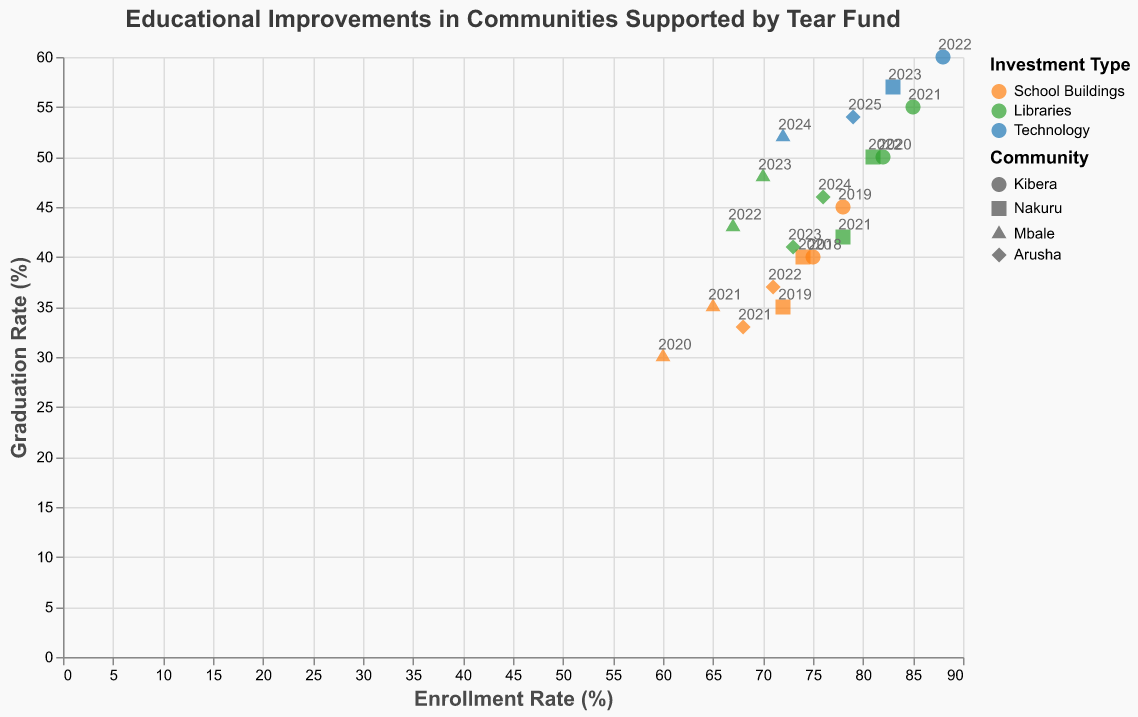How many communities have data points in this figure? The shape legend shows symbols representing different communities. There are four different symbols: circle, square, triangle, and diamond, indicating four communities.
Answer: Four What is the graduation rate for Nakuru in 2023? Find the data point associated with Nakuru in 2023 using its unique shape (square) and year label (2023). The scatter plot indicates a graduation rate of 57%.
Answer: 57% Which community had the highest enrollment rate in 2022? Locate the data points for 2022 and compare the enrollment rates for each community. Kibera had the highest enrollment rate in 2022, marked with a circle and an enrollment rate of 88%.
Answer: Kibera What is the range of investment amounts for library projects? Observe the color legend for libraries (green) and identify the investment amounts visually from these data points. The range is from 15,000 to 25,000 units.
Answer: 15,000 to 25,000 How has the graduation rate in Kibera changed from 2018 to 2022? Identify the data points for Kibera across the years 2018 to 2022. The graduation rates are 40% (2018), 45% (2019), 50% (2020), 55% (2021), and 60% (2022). The change from 2018 to 2022 is an increase by 20% (40% to 60%).
Answer: Increased by 20% Which investment type is associated with the highest average enrollment rate? Calculate the average enrollment rate for each investment type using the color legend to differentiate them: 
- School Buildings (orange): (75+78+72+74+60+65+68+71)/8 ≈ 70.38% 
- Libraries (green): (82+85+78+81+67+70+73+76)/8 ≈ 75.25% 
- Technology (blue): (88+83+72+79)/4 = 80.5%.
Technology has the highest average enrollment rate.
Answer: Technology In which year did the project "BrightFutures" in Mbale show the greatest improvement in graduation rate compared to the previous year? Focus on graduation rates for "BrightFutures" in Mbale annually. Note the differences: 
- 2021: 35% - 2020: 30% = 5%
- 2022: 43% - 2021: 35% = 8%
- 2023: 48% - 2022: 43% = 5%
- 2024: 52% - 2023: 48% = 4%.
The greatest improvement of 8% occurred from 2021 to 2022.
Answer: 2022 How many data points represent investments in technology? Use the color legend to identify blue points representing technology investments. Count these points in the scatter plot. There are four such data points.
Answer: Four Which community exhibits the largest increase in both enrollment and graduation rates over the observed period? Compare each community's first and last data point:
- Kibera: Enrollment 75% to 88% (+13%); Graduation 40% to 60% (+20%) 
- Nakuru: Enrollment 72% to 83% (+11%); Graduation 35% to 57% (+22%) 
- Mbale: Enrollment 60% to 72% (+12%); Graduation 30% to 52% (+22%)
- Arusha: Enrollment 68% to 79% (+11%); Graduation 33% to 54% (+21%)
Kibera has the largest combined increase (13% + 20% = 33%).
Answer: Kibera 